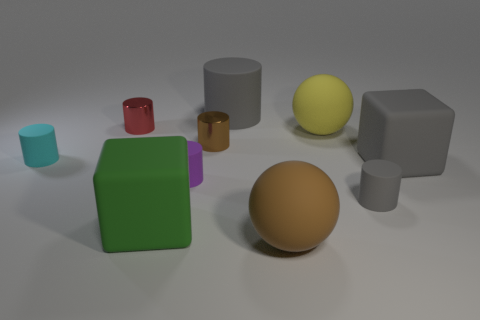Subtract 2 cylinders. How many cylinders are left? 4 Subtract all red cylinders. How many cylinders are left? 5 Subtract all tiny gray cylinders. How many cylinders are left? 5 Subtract all gray cylinders. Subtract all cyan blocks. How many cylinders are left? 4 Subtract all cubes. How many objects are left? 8 Add 5 rubber cylinders. How many rubber cylinders are left? 9 Add 3 large yellow spheres. How many large yellow spheres exist? 4 Subtract 1 brown spheres. How many objects are left? 9 Subtract all big yellow metallic things. Subtract all tiny red things. How many objects are left? 9 